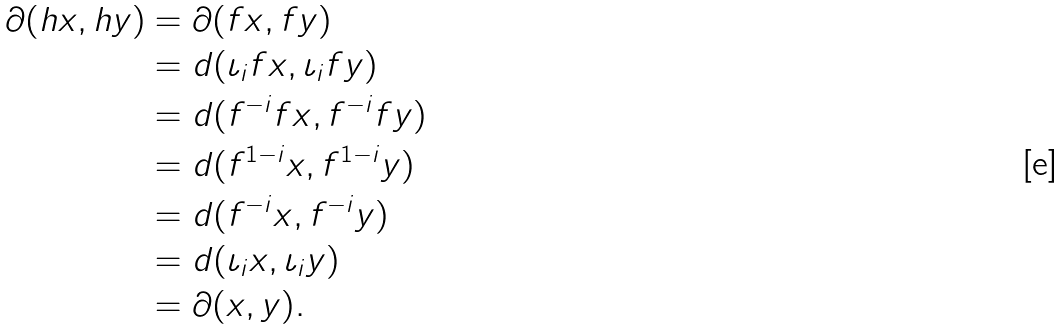<formula> <loc_0><loc_0><loc_500><loc_500>\partial ( h x , h y ) & = \partial ( f x , f y ) \\ & = d ( \iota _ { i } f x , \iota _ { i } f y ) \\ & = d ( f ^ { - i } f x , f ^ { - i } f y ) \\ & = d ( f ^ { 1 - i } x , f ^ { 1 - i } y ) \\ & = d ( f ^ { - i } x , f ^ { - i } y ) \\ & = d ( \iota _ { i } x , \iota _ { i } y ) \\ & = \partial ( x , y ) .</formula> 